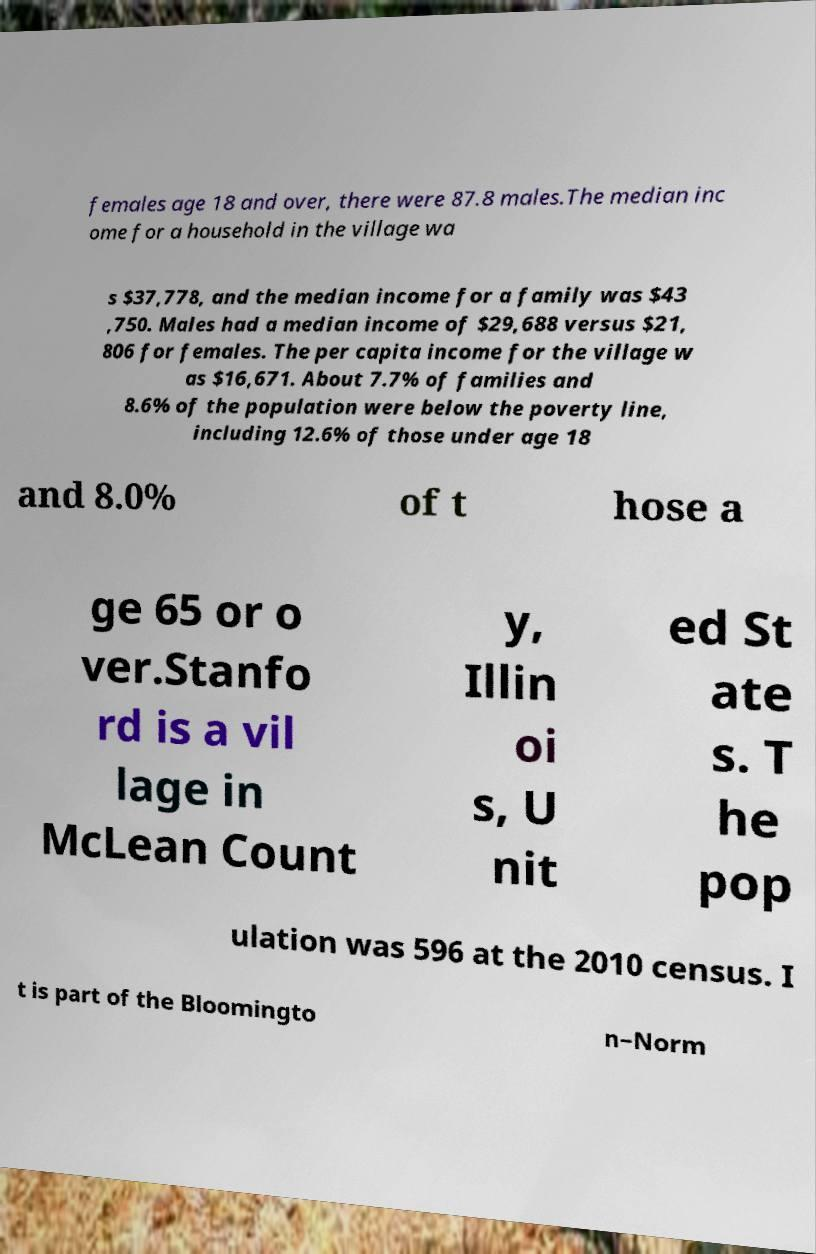For documentation purposes, I need the text within this image transcribed. Could you provide that? females age 18 and over, there were 87.8 males.The median inc ome for a household in the village wa s $37,778, and the median income for a family was $43 ,750. Males had a median income of $29,688 versus $21, 806 for females. The per capita income for the village w as $16,671. About 7.7% of families and 8.6% of the population were below the poverty line, including 12.6% of those under age 18 and 8.0% of t hose a ge 65 or o ver.Stanfo rd is a vil lage in McLean Count y, Illin oi s, U nit ed St ate s. T he pop ulation was 596 at the 2010 census. I t is part of the Bloomingto n–Norm 